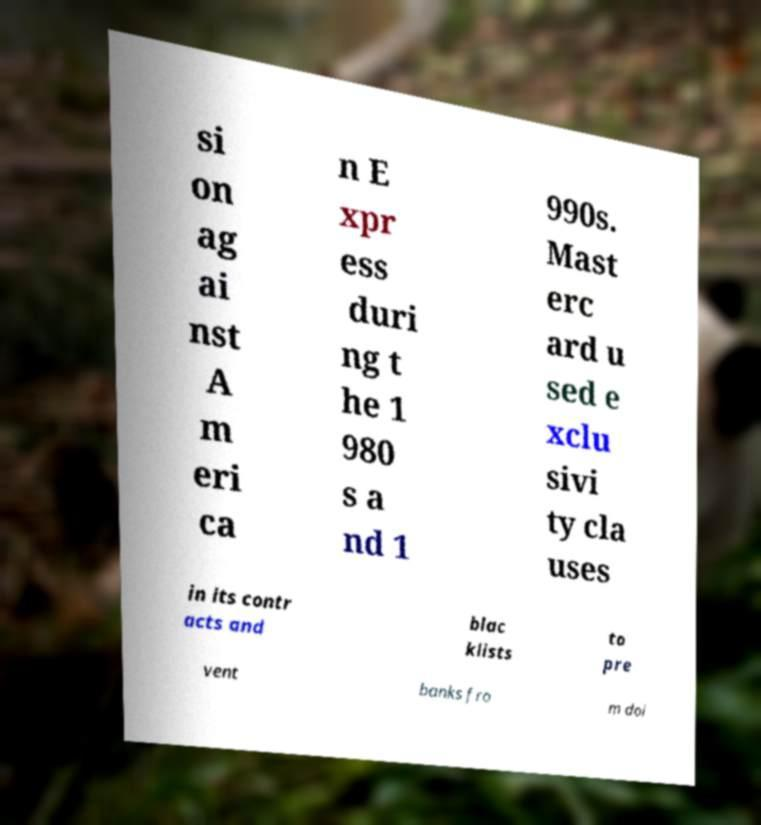Please identify and transcribe the text found in this image. si on ag ai nst A m eri ca n E xpr ess duri ng t he 1 980 s a nd 1 990s. Mast erc ard u sed e xclu sivi ty cla uses in its contr acts and blac klists to pre vent banks fro m doi 